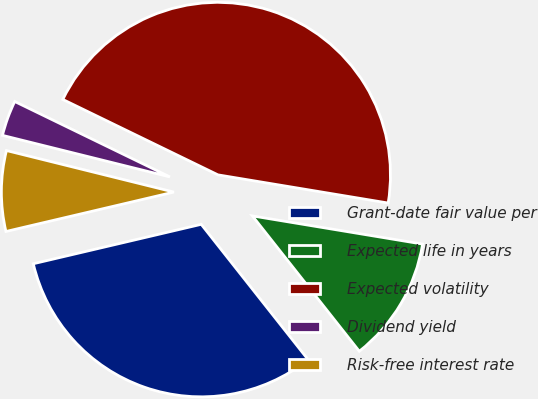Convert chart to OTSL. <chart><loc_0><loc_0><loc_500><loc_500><pie_chart><fcel>Grant-date fair value per<fcel>Expected life in years<fcel>Expected volatility<fcel>Dividend yield<fcel>Risk-free interest rate<nl><fcel>31.97%<fcel>11.75%<fcel>45.41%<fcel>3.33%<fcel>7.54%<nl></chart> 